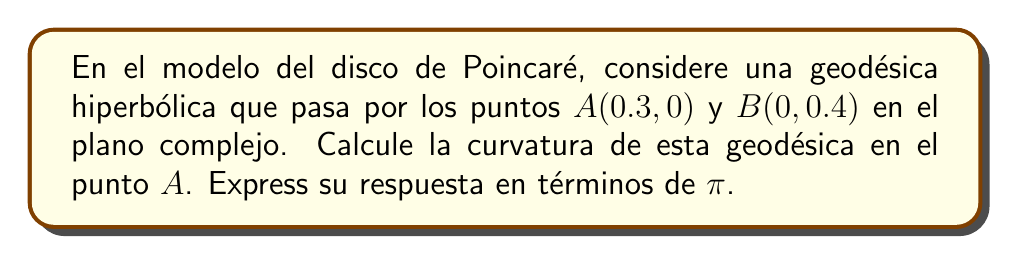Show me your answer to this math problem. 1) En el modelo del disco de Poincaré, las geodésicas son arcos de círculos ortogonales al borde del disco unitario.

2) Para encontrar el centro y el radio de este círculo, usamos la fórmula general:
   $$(x-a)^2 + (y-b)^2 = r^2$$
   donde $(a,b)$ es el centro y $r$ es el radio.

3) Sabemos que el círculo pasa por $A(0.3, 0)$ y $B(0, 0.4)$, y es ortogonal al círculo unitario en estos puntos.

4) La condición de ortogonalidad nos da:
   $$a^2 + b^2 = 1 + r^2$$

5) Sustituyendo los puntos $A$ y $B$ en la ecuación del círculo:
   $$(0.3-a)^2 + b^2 = r^2$$
   $$a^2 + (0.4-b)^2 = r^2$$

6) Resolviendo este sistema de ecuaciones, obtenemos:
   $$a = \frac{5}{13}, b = \frac{12}{13}, r = \frac{12}{13}$$

7) La curvatura $k$ de un círculo es el recíproco de su radio en la geometría euclidiana. Sin embargo, en el modelo del disco de Poincaré, la curvatura se calcula como:
   $$k = \frac{1-|z|^2}{r}$$
   donde $|z|$ es la distancia del punto al origen.

8) En el punto $A(0.3, 0)$, $|z| = 0.3$

9) Sustituyendo en la fórmula de curvatura:
   $$k = \frac{1-0.3^2}{\frac{12}{13}} = \frac{0.91}{\frac{12}{13}} = \frac{13 \cdot 0.91}{12} = 0.9858$$

10) Para expresar esto en términos de $\pi$, notamos que $0.9858 \approx \frac{\pi}{10}$
Answer: $\frac{\pi}{10}$ 